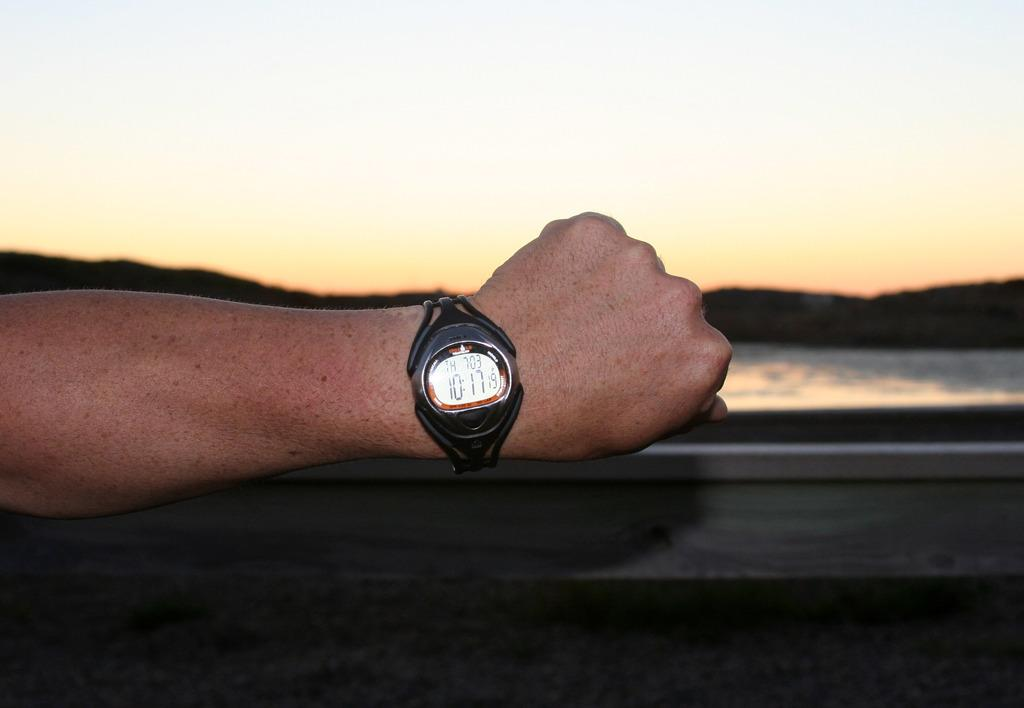What is in the foreground of the image? There is a person's hand on a fence in the foreground. What can be seen in the background of the image? Water, mountains, and the sky are visible in the background. Can you describe the time of day the image may have been taken? The image may have been taken in the evening. What location might the image have been taken near? The image may have been taken near a lake. What type of bone can be seen sticking out of the water in the image? There is no bone visible in the image; it only shows water, mountains, and the sky in the background. 